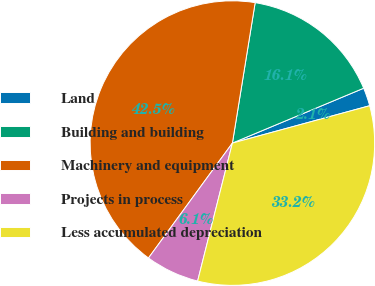Convert chart to OTSL. <chart><loc_0><loc_0><loc_500><loc_500><pie_chart><fcel>Land<fcel>Building and building<fcel>Machinery and equipment<fcel>Projects in process<fcel>Less accumulated depreciation<nl><fcel>2.07%<fcel>16.14%<fcel>42.52%<fcel>6.11%<fcel>33.16%<nl></chart> 